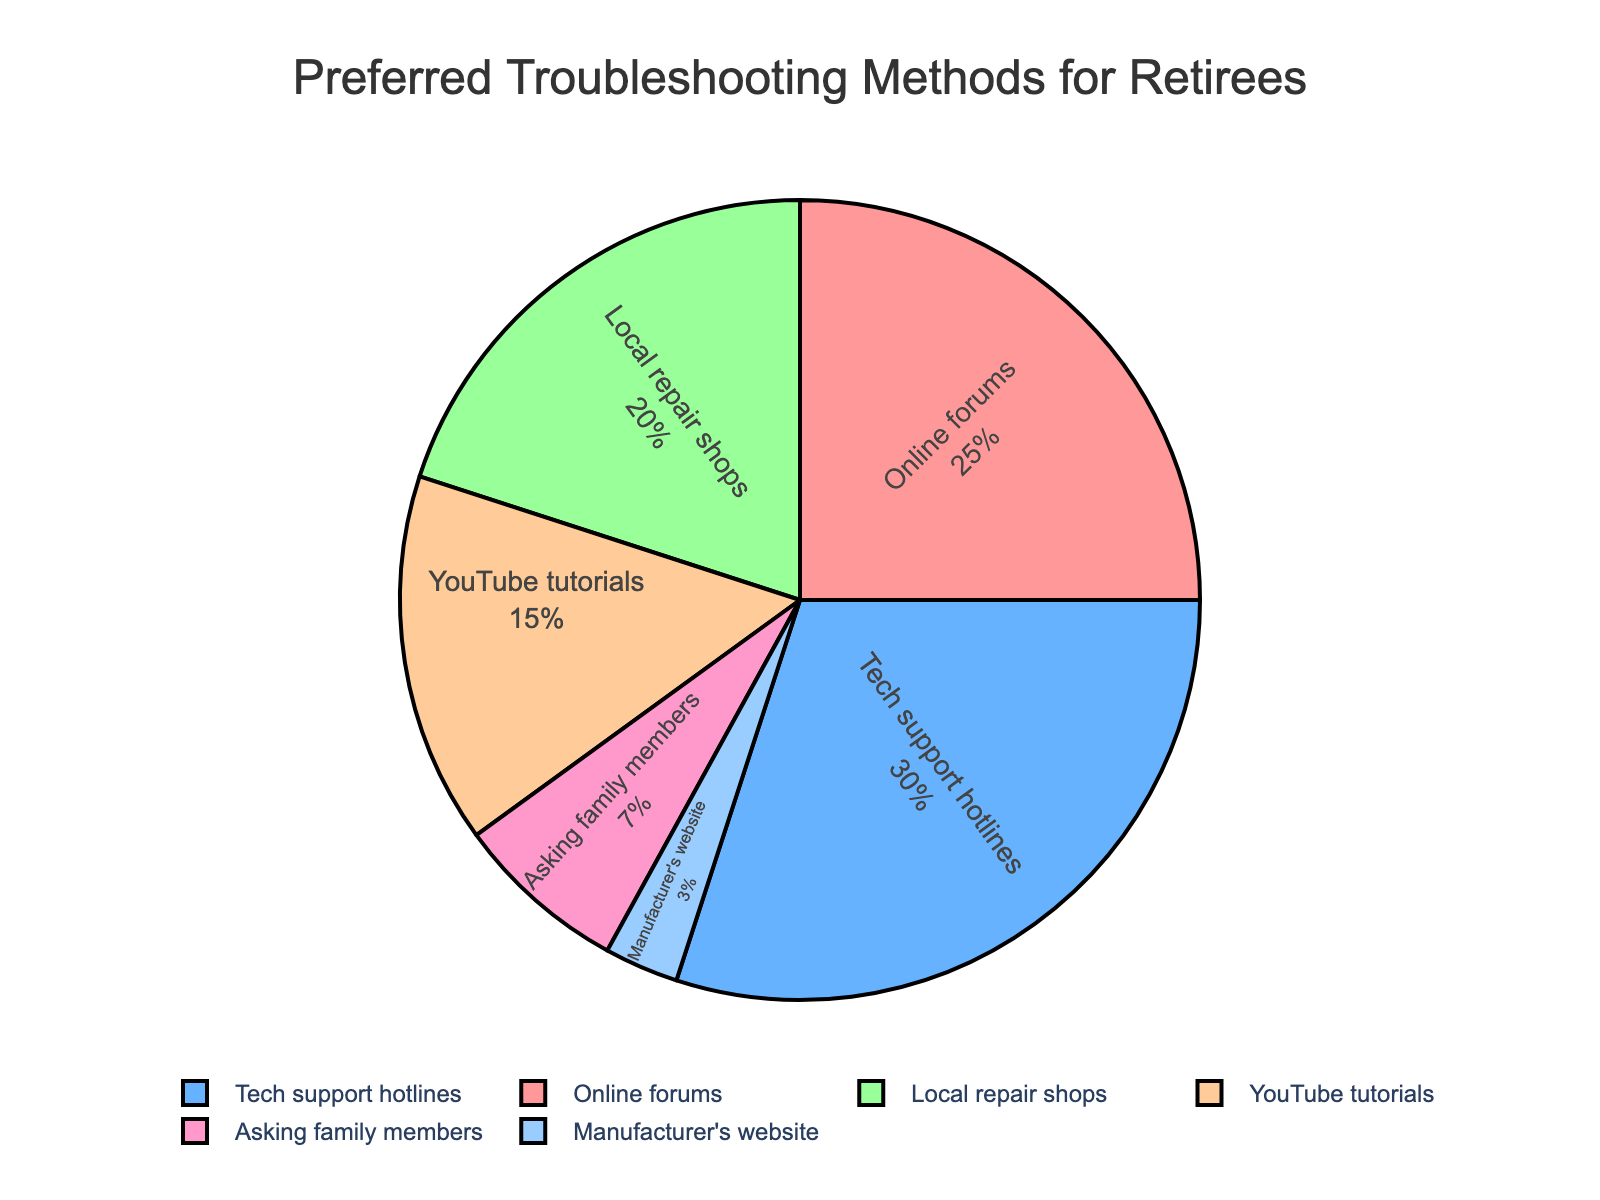What's the most preferred troubleshooting method by retirees? The most preferred troubleshooting method is the one with the highest percentage. According to the pie chart, Tech support hotlines have the highest percentage at 30%.
Answer: Tech support hotlines Which two methods have the smallest percentage, and what is their combined percentage? The two methods with the smallest percentages are the Manufacturer's website at 3% and Asking family members at 7%. Their combined percentage is 3% + 7% = 10%.
Answer: 10% How much more popular are tech support hotlines compared to local repair shops? To find how much more popular tech support hotlines are compared to local repair shops, subtract the percentage of Local repair shops (20%) from Tech support hotlines (30%). 30% - 20% = 10%.
Answer: 10% Which segments are represented by the colors red and blue? By noting the positions on the pie chart and considering the colors listed in the code, we see that red corresponds to "Online forums" and blue corresponds to "Tech support hotlines".
Answer: Online forums and Tech support hotlines What percentage of retirees prefer online resources (Online forums, YouTube tutorials, and Manufacturer's website) for troubleshooting? To find the percentage of retirees who prefer online resources, add the percentages for Online forums (25%), YouTube tutorials (15%), and Manufacturer's website (3%). 25% + 15% + 3% = 43%.
Answer: 43% Compare the combined percentage of those who prefer local (Local repair shops) versus human assistance options (Tech support hotlines and Asking family members). Which is higher and by how much? Local repair shops have 20%. The combined percentage for human assistance options (Tech support hotlines 30% and Asking family members 7%) is 37%. Comparing the two, 37% - 20% = 17%.
Answer: Human assistance by 17% Which method in the pie chart is represented by a green color? By noting the color code positions in the provided plot code and looking at the pie chart, the green segment corresponds to "Local repair shops".
Answer: Local repair shops How much larger is the combined percentage of the top two methods compared to the least preferred method? The top two methods are Tech support hotlines (30%) and Online forums (25%), so their combined percentage is 30% + 25% = 55%. The least preferred method is Manufacturer's website at 3%. 55% - 3% = 52%.
Answer: 52% What is the difference in percentage between retirees who prefer YouTube tutorials and those who prefer Local repair shops? The percentage for YouTube tutorials is 15%, and for Local repair shops it's 20%. The difference is 20% - 15% = 5%.
Answer: 5% 